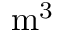Convert formula to latex. <formula><loc_0><loc_0><loc_500><loc_500>m ^ { 3 }</formula> 